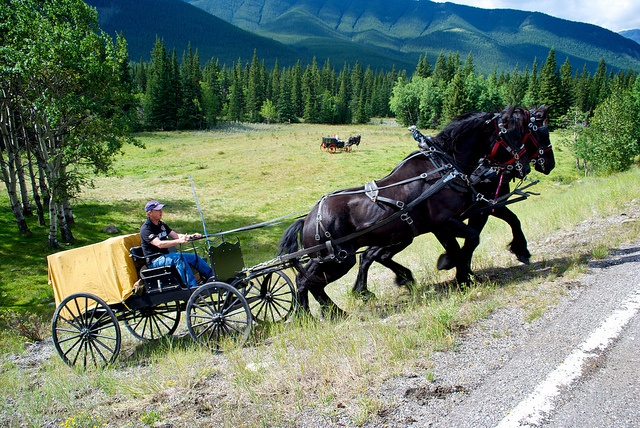Describe the objects in this image and their specific colors. I can see horse in darkgreen, black, gray, and darkgray tones, horse in darkgreen, black, gray, and khaki tones, people in darkgreen, black, navy, blue, and lightgray tones, horse in darkgreen, black, gray, darkgray, and tan tones, and people in darkgreen, white, tan, khaki, and blue tones in this image. 